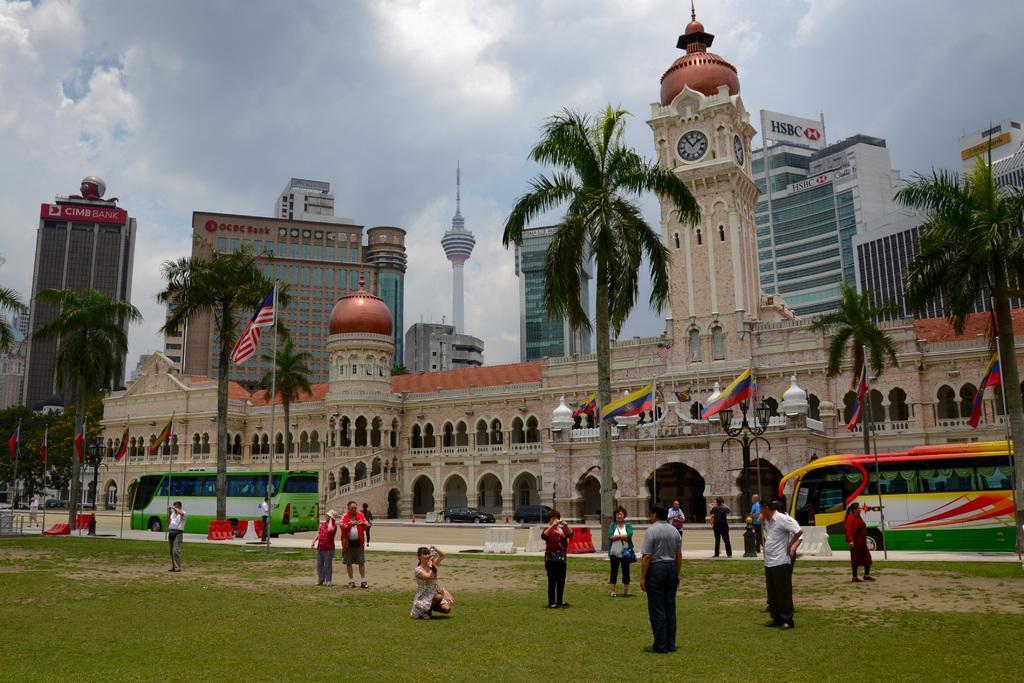In one or two sentences, can you explain what this image depicts? In this image, I can see the buildings, trees and vehicles on the road. In front of the buildings, I can see few people standing on the grass, a person in squat position and flags hanging to the poles. In the background, there is the sky. 